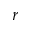Convert formula to latex. <formula><loc_0><loc_0><loc_500><loc_500>r</formula> 